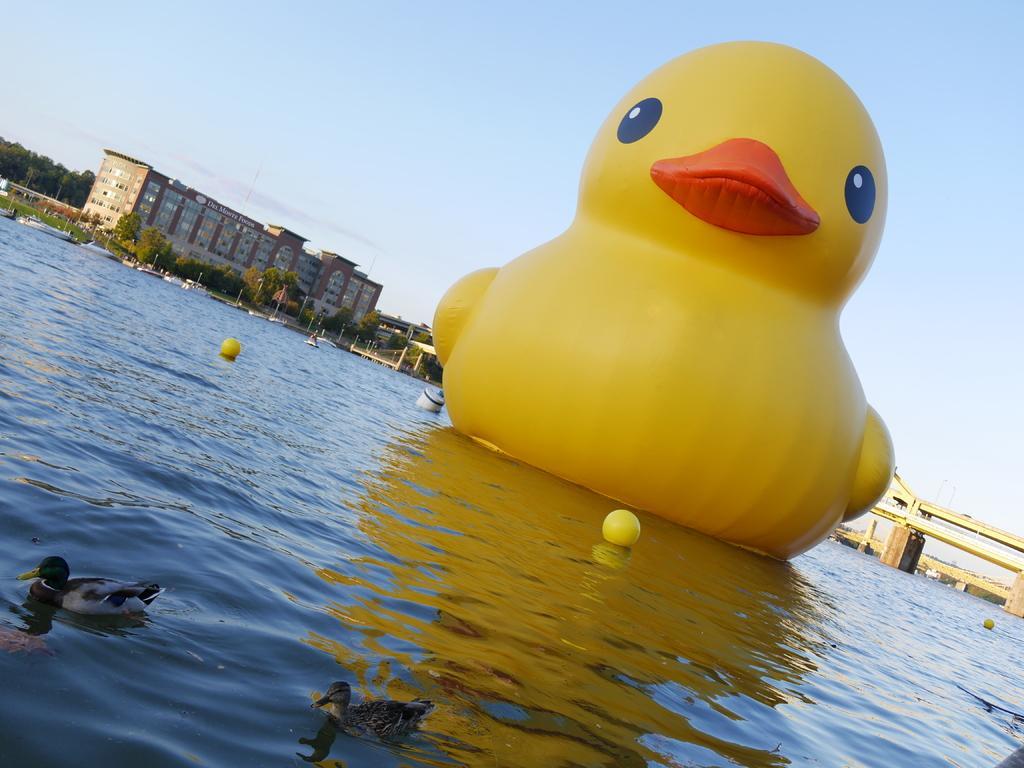How would you summarize this image in a sentence or two? In the front of the image I can see water, ducks, balls and a giant inflatable duck. In the background of the image there is a bridge, pillars, trees, building, poles, boats and sky. 